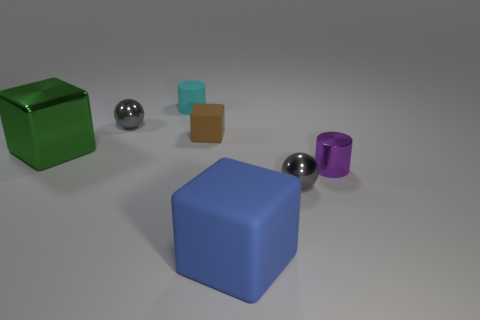What materials do the objects in the image appear to be made of? The objects in the image seem to be made of various materials. The green and blue cubes have a matte appearance suggestive of rubber, the two spheres exhibit a metallic sheen, and the small brown cube appears to be wooden due to its texture and coloration. The purple object has a smooth surface which might indicate a plastic or ceramic material. 